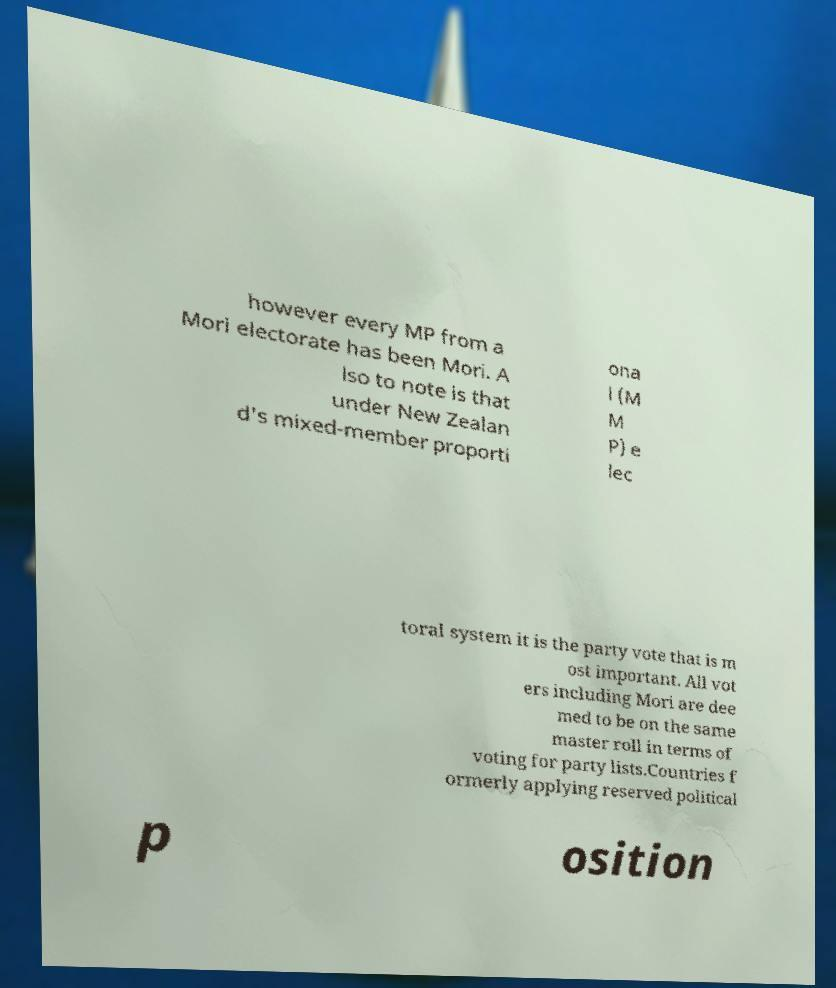Please read and relay the text visible in this image. What does it say? however every MP from a Mori electorate has been Mori. A lso to note is that under New Zealan d's mixed-member proporti ona l (M M P) e lec toral system it is the party vote that is m ost important. All vot ers including Mori are dee med to be on the same master roll in terms of voting for party lists.Countries f ormerly applying reserved political p osition 